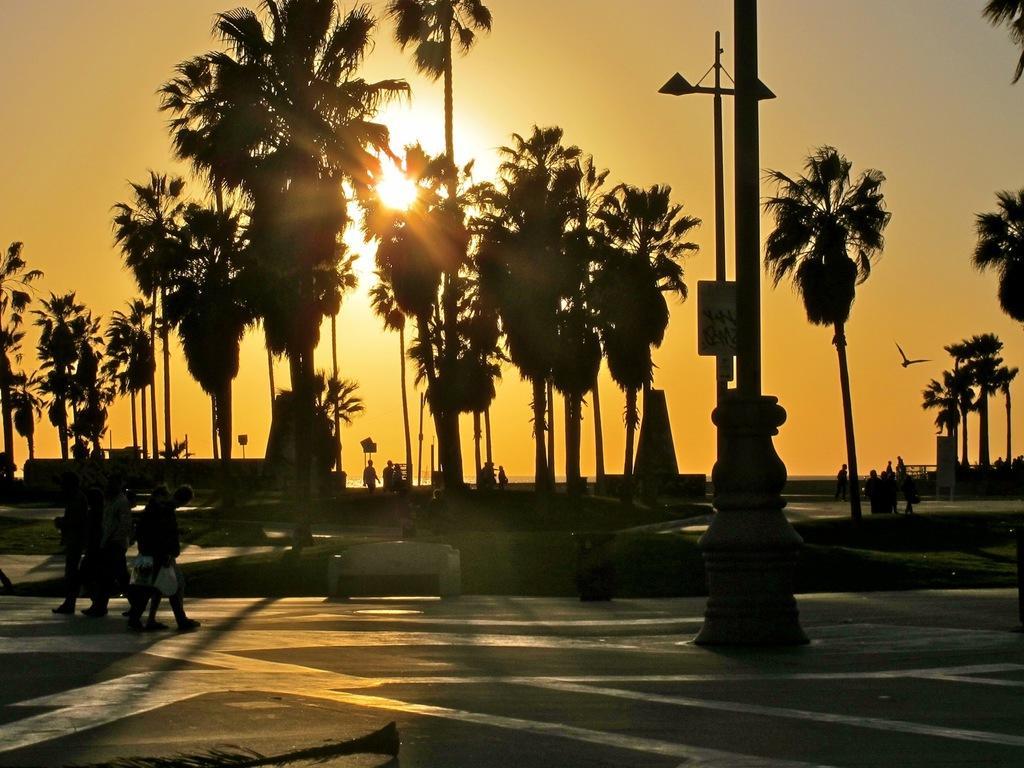In one or two sentences, can you explain what this image depicts? In this image there are people walking on the road. Right side there is a pole on the pavement. Behind there is a board attached to a street light. There are people walking on the path. There are trees on the grassland. Right side a bird is flying in the air. Background there is sky having a son. 